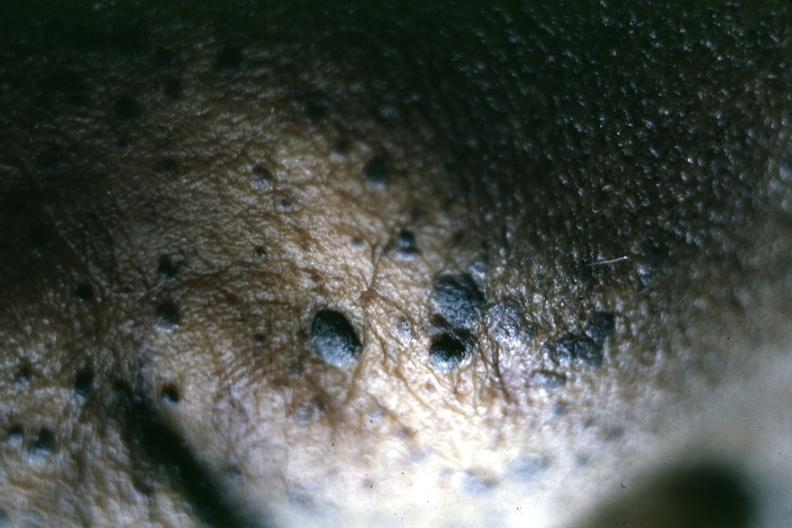s seborrheic keratosis present?
Answer the question using a single word or phrase. Yes 